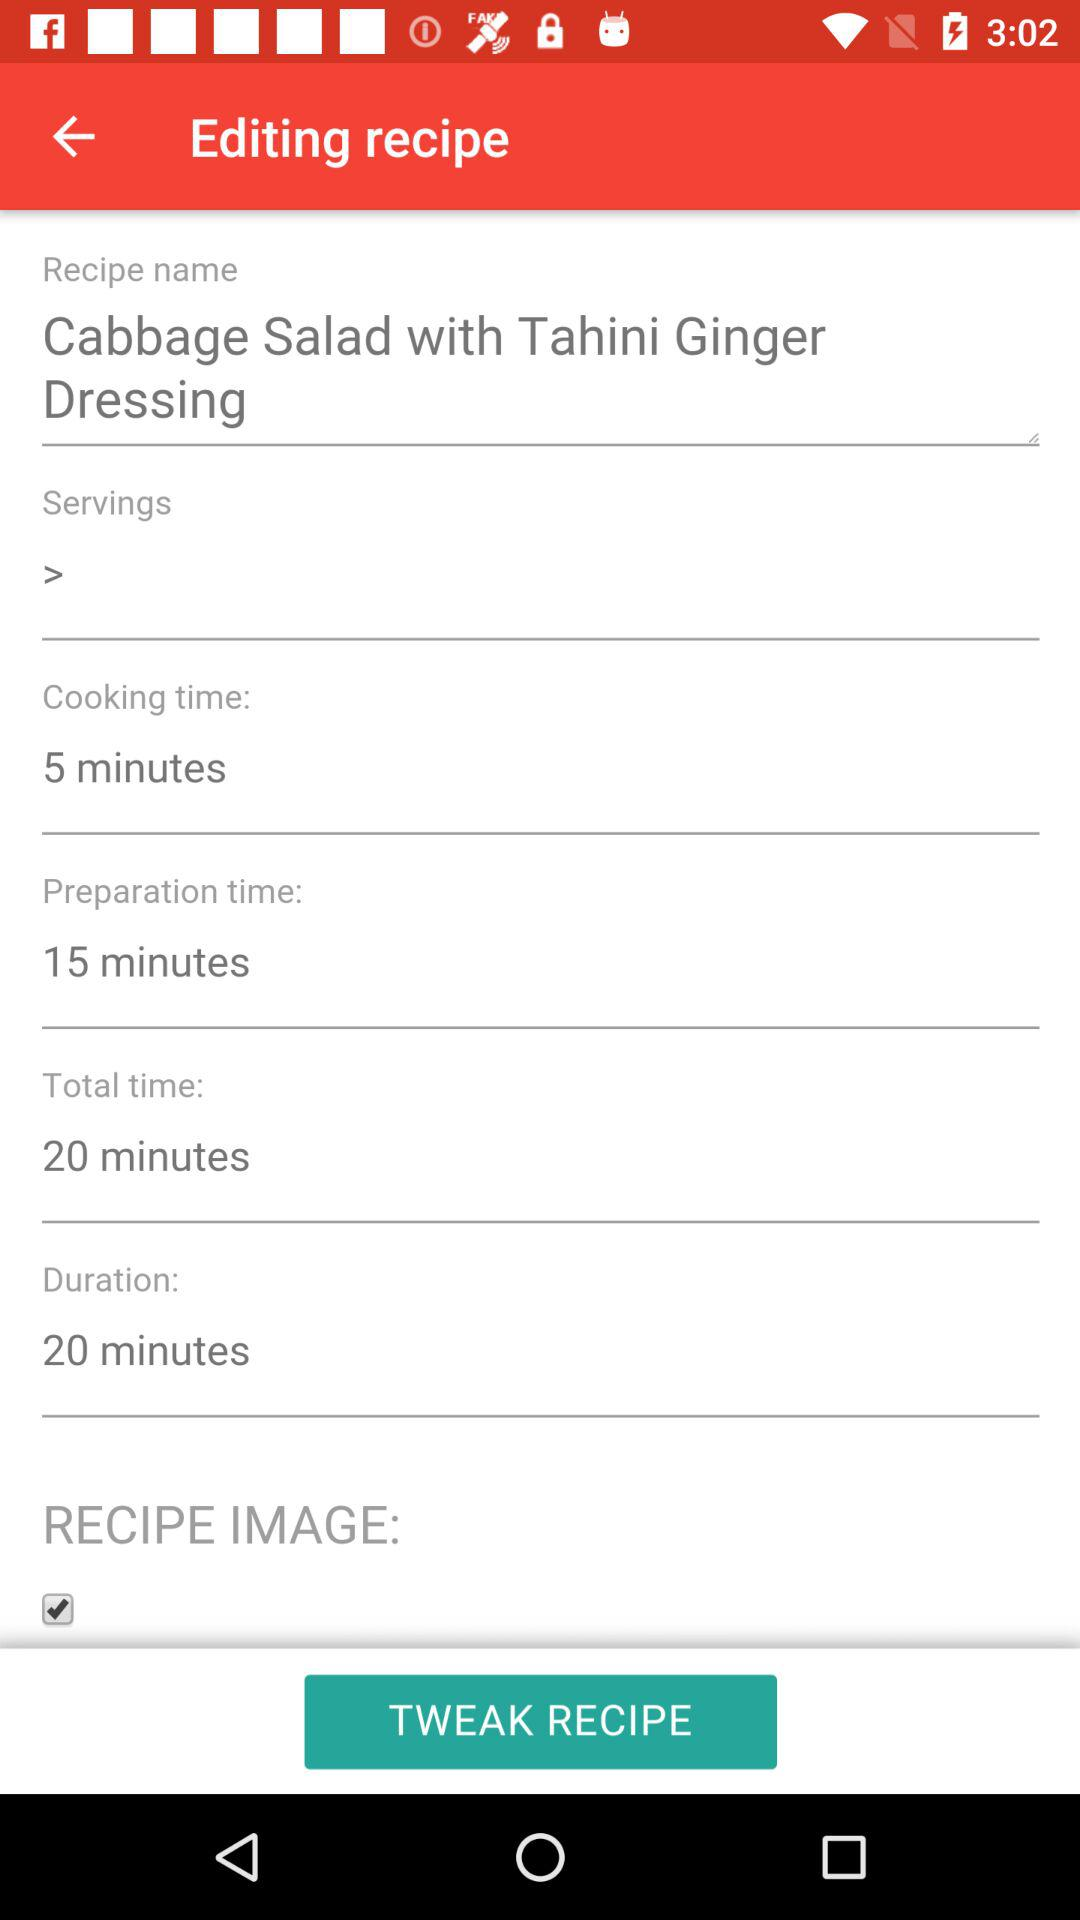What is the total time of the recipe?
Answer the question using a single word or phrase. 20 minutes 